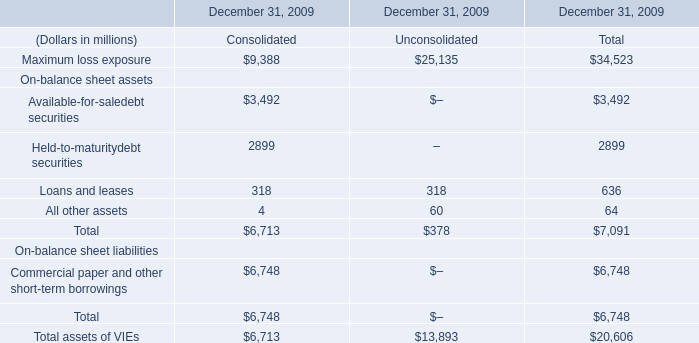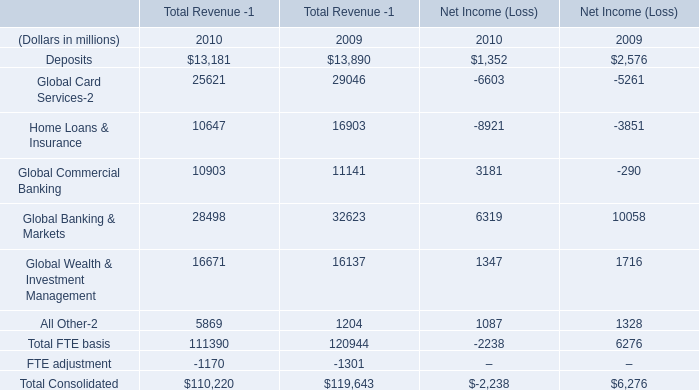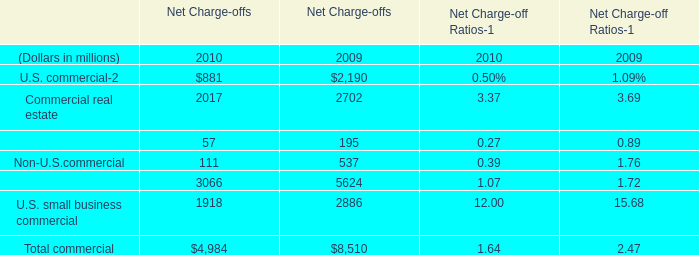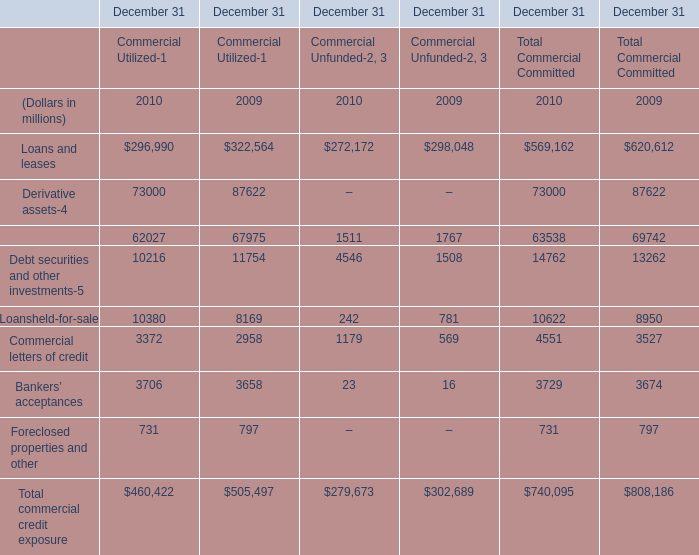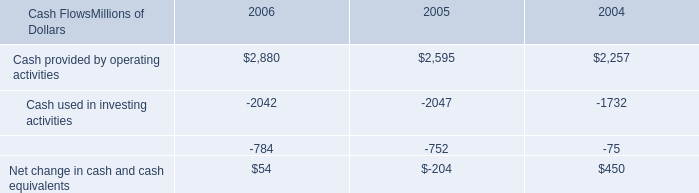What's the growth rate of commercial letters of credit for Total Commercial Committed in 2020? (in million) 
Computations: ((4551 - 3527) / 3527)
Answer: 0.29033. 